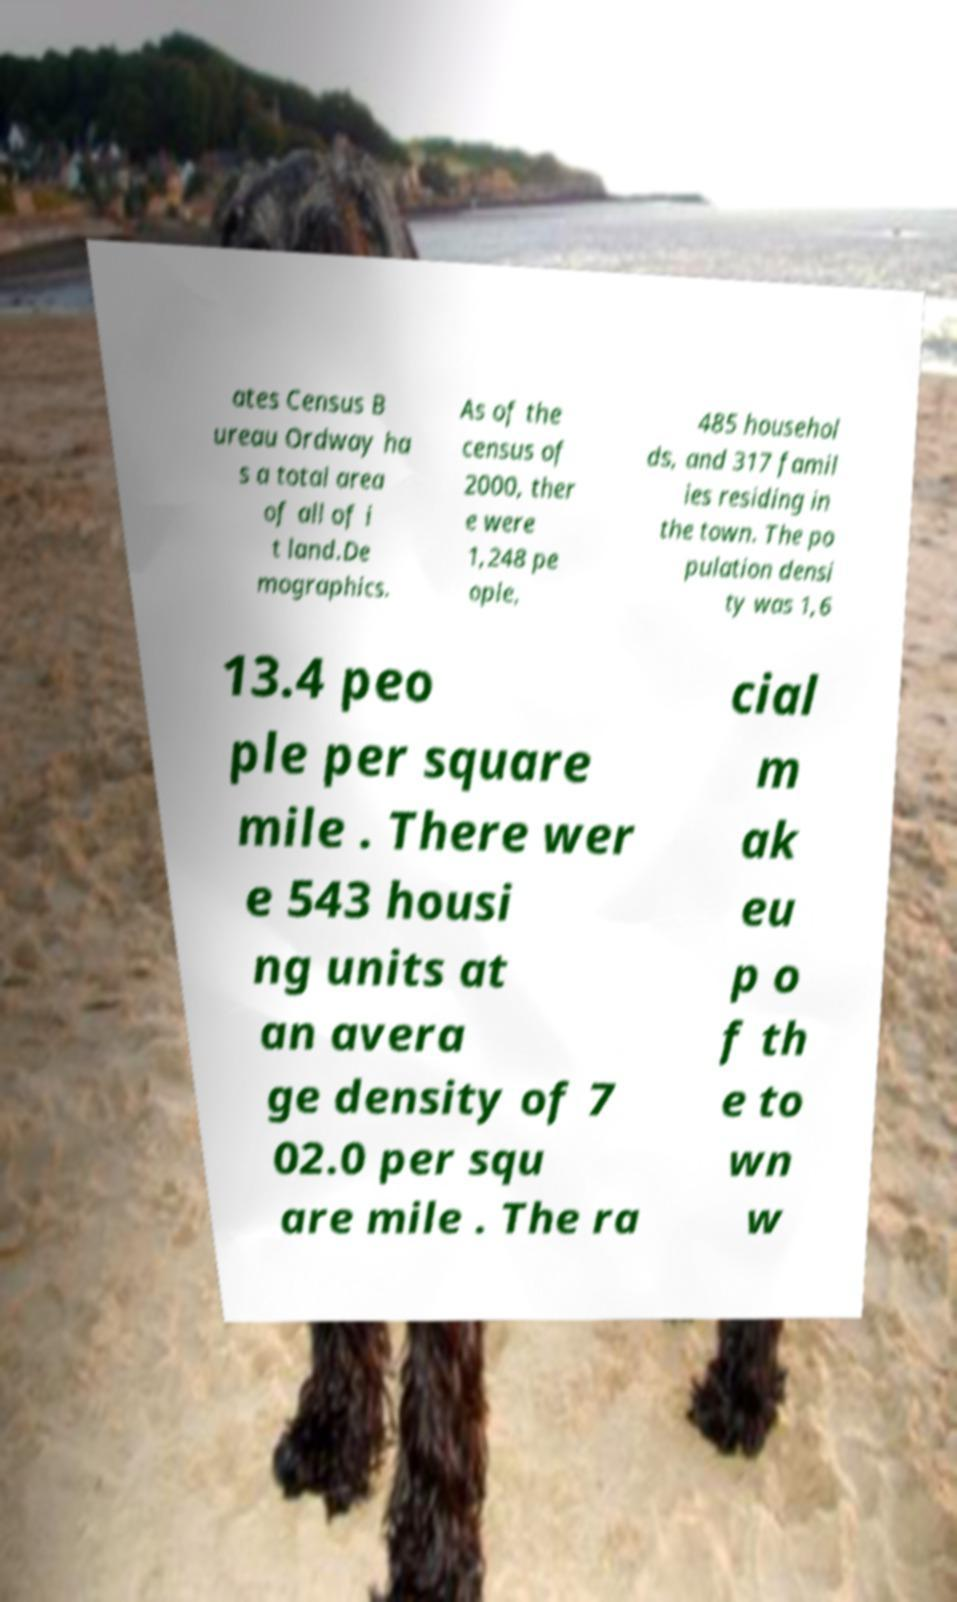Can you accurately transcribe the text from the provided image for me? ates Census B ureau Ordway ha s a total area of all of i t land.De mographics. As of the census of 2000, ther e were 1,248 pe ople, 485 househol ds, and 317 famil ies residing in the town. The po pulation densi ty was 1,6 13.4 peo ple per square mile . There wer e 543 housi ng units at an avera ge density of 7 02.0 per squ are mile . The ra cial m ak eu p o f th e to wn w 